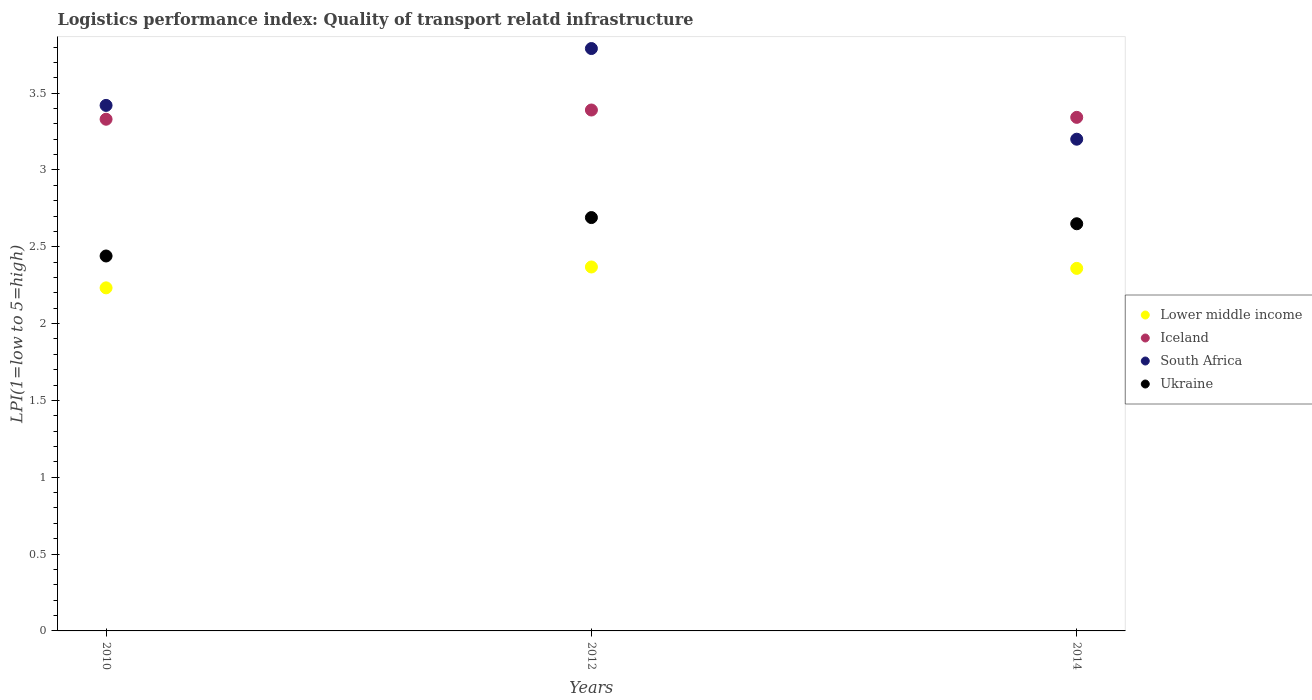What is the logistics performance index in Ukraine in 2012?
Keep it short and to the point. 2.69. Across all years, what is the maximum logistics performance index in Iceland?
Offer a very short reply. 3.39. Across all years, what is the minimum logistics performance index in Iceland?
Ensure brevity in your answer.  3.33. In which year was the logistics performance index in Lower middle income minimum?
Provide a succinct answer. 2010. What is the total logistics performance index in Iceland in the graph?
Offer a terse response. 10.06. What is the difference between the logistics performance index in Ukraine in 2012 and that in 2014?
Give a very brief answer. 0.04. What is the difference between the logistics performance index in South Africa in 2014 and the logistics performance index in Iceland in 2012?
Ensure brevity in your answer.  -0.19. What is the average logistics performance index in Iceland per year?
Offer a terse response. 3.35. In the year 2010, what is the difference between the logistics performance index in South Africa and logistics performance index in Iceland?
Your answer should be very brief. 0.09. What is the ratio of the logistics performance index in Lower middle income in 2010 to that in 2012?
Give a very brief answer. 0.94. Is the logistics performance index in South Africa in 2010 less than that in 2012?
Provide a short and direct response. Yes. Is the difference between the logistics performance index in South Africa in 2010 and 2014 greater than the difference between the logistics performance index in Iceland in 2010 and 2014?
Offer a very short reply. Yes. What is the difference between the highest and the second highest logistics performance index in Ukraine?
Provide a short and direct response. 0.04. What is the difference between the highest and the lowest logistics performance index in Lower middle income?
Your answer should be compact. 0.14. In how many years, is the logistics performance index in Ukraine greater than the average logistics performance index in Ukraine taken over all years?
Your answer should be compact. 2. Does the logistics performance index in Lower middle income monotonically increase over the years?
Provide a short and direct response. No. Is the logistics performance index in Iceland strictly less than the logistics performance index in Lower middle income over the years?
Provide a short and direct response. No. How many years are there in the graph?
Offer a very short reply. 3. Does the graph contain any zero values?
Ensure brevity in your answer.  No. Does the graph contain grids?
Your response must be concise. No. Where does the legend appear in the graph?
Provide a succinct answer. Center right. What is the title of the graph?
Offer a very short reply. Logistics performance index: Quality of transport relatd infrastructure. What is the label or title of the Y-axis?
Ensure brevity in your answer.  LPI(1=low to 5=high). What is the LPI(1=low to 5=high) in Lower middle income in 2010?
Your answer should be compact. 2.23. What is the LPI(1=low to 5=high) in Iceland in 2010?
Give a very brief answer. 3.33. What is the LPI(1=low to 5=high) in South Africa in 2010?
Provide a short and direct response. 3.42. What is the LPI(1=low to 5=high) of Ukraine in 2010?
Provide a short and direct response. 2.44. What is the LPI(1=low to 5=high) in Lower middle income in 2012?
Your answer should be very brief. 2.37. What is the LPI(1=low to 5=high) of Iceland in 2012?
Offer a terse response. 3.39. What is the LPI(1=low to 5=high) of South Africa in 2012?
Your response must be concise. 3.79. What is the LPI(1=low to 5=high) in Ukraine in 2012?
Ensure brevity in your answer.  2.69. What is the LPI(1=low to 5=high) of Lower middle income in 2014?
Make the answer very short. 2.36. What is the LPI(1=low to 5=high) of Iceland in 2014?
Provide a succinct answer. 3.34. What is the LPI(1=low to 5=high) in South Africa in 2014?
Make the answer very short. 3.2. What is the LPI(1=low to 5=high) in Ukraine in 2014?
Make the answer very short. 2.65. Across all years, what is the maximum LPI(1=low to 5=high) of Lower middle income?
Your answer should be compact. 2.37. Across all years, what is the maximum LPI(1=low to 5=high) in Iceland?
Your answer should be compact. 3.39. Across all years, what is the maximum LPI(1=low to 5=high) in South Africa?
Offer a very short reply. 3.79. Across all years, what is the maximum LPI(1=low to 5=high) in Ukraine?
Your answer should be very brief. 2.69. Across all years, what is the minimum LPI(1=low to 5=high) in Lower middle income?
Make the answer very short. 2.23. Across all years, what is the minimum LPI(1=low to 5=high) of Iceland?
Keep it short and to the point. 3.33. Across all years, what is the minimum LPI(1=low to 5=high) in South Africa?
Make the answer very short. 3.2. Across all years, what is the minimum LPI(1=low to 5=high) of Ukraine?
Give a very brief answer. 2.44. What is the total LPI(1=low to 5=high) of Lower middle income in the graph?
Your answer should be very brief. 6.96. What is the total LPI(1=low to 5=high) of Iceland in the graph?
Provide a succinct answer. 10.06. What is the total LPI(1=low to 5=high) in South Africa in the graph?
Provide a short and direct response. 10.41. What is the total LPI(1=low to 5=high) of Ukraine in the graph?
Provide a succinct answer. 7.78. What is the difference between the LPI(1=low to 5=high) in Lower middle income in 2010 and that in 2012?
Ensure brevity in your answer.  -0.14. What is the difference between the LPI(1=low to 5=high) of Iceland in 2010 and that in 2012?
Keep it short and to the point. -0.06. What is the difference between the LPI(1=low to 5=high) in South Africa in 2010 and that in 2012?
Your answer should be very brief. -0.37. What is the difference between the LPI(1=low to 5=high) of Lower middle income in 2010 and that in 2014?
Your answer should be very brief. -0.13. What is the difference between the LPI(1=low to 5=high) in Iceland in 2010 and that in 2014?
Give a very brief answer. -0.01. What is the difference between the LPI(1=low to 5=high) of South Africa in 2010 and that in 2014?
Give a very brief answer. 0.22. What is the difference between the LPI(1=low to 5=high) in Ukraine in 2010 and that in 2014?
Make the answer very short. -0.21. What is the difference between the LPI(1=low to 5=high) of Lower middle income in 2012 and that in 2014?
Your answer should be very brief. 0.01. What is the difference between the LPI(1=low to 5=high) in Iceland in 2012 and that in 2014?
Your response must be concise. 0.05. What is the difference between the LPI(1=low to 5=high) of South Africa in 2012 and that in 2014?
Make the answer very short. 0.59. What is the difference between the LPI(1=low to 5=high) of Ukraine in 2012 and that in 2014?
Provide a short and direct response. 0.04. What is the difference between the LPI(1=low to 5=high) of Lower middle income in 2010 and the LPI(1=low to 5=high) of Iceland in 2012?
Keep it short and to the point. -1.16. What is the difference between the LPI(1=low to 5=high) in Lower middle income in 2010 and the LPI(1=low to 5=high) in South Africa in 2012?
Ensure brevity in your answer.  -1.56. What is the difference between the LPI(1=low to 5=high) in Lower middle income in 2010 and the LPI(1=low to 5=high) in Ukraine in 2012?
Keep it short and to the point. -0.46. What is the difference between the LPI(1=low to 5=high) in Iceland in 2010 and the LPI(1=low to 5=high) in South Africa in 2012?
Offer a terse response. -0.46. What is the difference between the LPI(1=low to 5=high) of Iceland in 2010 and the LPI(1=low to 5=high) of Ukraine in 2012?
Ensure brevity in your answer.  0.64. What is the difference between the LPI(1=low to 5=high) in South Africa in 2010 and the LPI(1=low to 5=high) in Ukraine in 2012?
Keep it short and to the point. 0.73. What is the difference between the LPI(1=low to 5=high) in Lower middle income in 2010 and the LPI(1=low to 5=high) in Iceland in 2014?
Make the answer very short. -1.11. What is the difference between the LPI(1=low to 5=high) in Lower middle income in 2010 and the LPI(1=low to 5=high) in South Africa in 2014?
Your answer should be very brief. -0.97. What is the difference between the LPI(1=low to 5=high) in Lower middle income in 2010 and the LPI(1=low to 5=high) in Ukraine in 2014?
Your answer should be compact. -0.42. What is the difference between the LPI(1=low to 5=high) of Iceland in 2010 and the LPI(1=low to 5=high) of South Africa in 2014?
Your answer should be very brief. 0.13. What is the difference between the LPI(1=low to 5=high) in Iceland in 2010 and the LPI(1=low to 5=high) in Ukraine in 2014?
Your answer should be compact. 0.68. What is the difference between the LPI(1=low to 5=high) of South Africa in 2010 and the LPI(1=low to 5=high) of Ukraine in 2014?
Make the answer very short. 0.77. What is the difference between the LPI(1=low to 5=high) of Lower middle income in 2012 and the LPI(1=low to 5=high) of Iceland in 2014?
Provide a short and direct response. -0.97. What is the difference between the LPI(1=low to 5=high) in Lower middle income in 2012 and the LPI(1=low to 5=high) in South Africa in 2014?
Make the answer very short. -0.83. What is the difference between the LPI(1=low to 5=high) of Lower middle income in 2012 and the LPI(1=low to 5=high) of Ukraine in 2014?
Offer a terse response. -0.28. What is the difference between the LPI(1=low to 5=high) in Iceland in 2012 and the LPI(1=low to 5=high) in South Africa in 2014?
Keep it short and to the point. 0.19. What is the difference between the LPI(1=low to 5=high) in Iceland in 2012 and the LPI(1=low to 5=high) in Ukraine in 2014?
Keep it short and to the point. 0.74. What is the difference between the LPI(1=low to 5=high) in South Africa in 2012 and the LPI(1=low to 5=high) in Ukraine in 2014?
Your response must be concise. 1.14. What is the average LPI(1=low to 5=high) of Lower middle income per year?
Provide a short and direct response. 2.32. What is the average LPI(1=low to 5=high) in Iceland per year?
Keep it short and to the point. 3.35. What is the average LPI(1=low to 5=high) of South Africa per year?
Provide a short and direct response. 3.47. What is the average LPI(1=low to 5=high) in Ukraine per year?
Your answer should be compact. 2.59. In the year 2010, what is the difference between the LPI(1=low to 5=high) of Lower middle income and LPI(1=low to 5=high) of Iceland?
Give a very brief answer. -1.1. In the year 2010, what is the difference between the LPI(1=low to 5=high) of Lower middle income and LPI(1=low to 5=high) of South Africa?
Your answer should be very brief. -1.19. In the year 2010, what is the difference between the LPI(1=low to 5=high) of Lower middle income and LPI(1=low to 5=high) of Ukraine?
Offer a terse response. -0.21. In the year 2010, what is the difference between the LPI(1=low to 5=high) of Iceland and LPI(1=low to 5=high) of South Africa?
Your answer should be very brief. -0.09. In the year 2010, what is the difference between the LPI(1=low to 5=high) of Iceland and LPI(1=low to 5=high) of Ukraine?
Keep it short and to the point. 0.89. In the year 2012, what is the difference between the LPI(1=low to 5=high) in Lower middle income and LPI(1=low to 5=high) in Iceland?
Provide a short and direct response. -1.02. In the year 2012, what is the difference between the LPI(1=low to 5=high) in Lower middle income and LPI(1=low to 5=high) in South Africa?
Offer a terse response. -1.42. In the year 2012, what is the difference between the LPI(1=low to 5=high) in Lower middle income and LPI(1=low to 5=high) in Ukraine?
Make the answer very short. -0.32. In the year 2012, what is the difference between the LPI(1=low to 5=high) in Iceland and LPI(1=low to 5=high) in South Africa?
Your answer should be very brief. -0.4. In the year 2014, what is the difference between the LPI(1=low to 5=high) of Lower middle income and LPI(1=low to 5=high) of Iceland?
Keep it short and to the point. -0.98. In the year 2014, what is the difference between the LPI(1=low to 5=high) in Lower middle income and LPI(1=low to 5=high) in South Africa?
Provide a succinct answer. -0.84. In the year 2014, what is the difference between the LPI(1=low to 5=high) of Lower middle income and LPI(1=low to 5=high) of Ukraine?
Your answer should be compact. -0.29. In the year 2014, what is the difference between the LPI(1=low to 5=high) of Iceland and LPI(1=low to 5=high) of South Africa?
Your response must be concise. 0.14. In the year 2014, what is the difference between the LPI(1=low to 5=high) of Iceland and LPI(1=low to 5=high) of Ukraine?
Your answer should be compact. 0.69. In the year 2014, what is the difference between the LPI(1=low to 5=high) of South Africa and LPI(1=low to 5=high) of Ukraine?
Offer a very short reply. 0.55. What is the ratio of the LPI(1=low to 5=high) of Lower middle income in 2010 to that in 2012?
Your response must be concise. 0.94. What is the ratio of the LPI(1=low to 5=high) of Iceland in 2010 to that in 2012?
Give a very brief answer. 0.98. What is the ratio of the LPI(1=low to 5=high) of South Africa in 2010 to that in 2012?
Ensure brevity in your answer.  0.9. What is the ratio of the LPI(1=low to 5=high) of Ukraine in 2010 to that in 2012?
Your answer should be compact. 0.91. What is the ratio of the LPI(1=low to 5=high) of Lower middle income in 2010 to that in 2014?
Offer a very short reply. 0.95. What is the ratio of the LPI(1=low to 5=high) of Iceland in 2010 to that in 2014?
Ensure brevity in your answer.  1. What is the ratio of the LPI(1=low to 5=high) of South Africa in 2010 to that in 2014?
Your answer should be very brief. 1.07. What is the ratio of the LPI(1=low to 5=high) in Ukraine in 2010 to that in 2014?
Keep it short and to the point. 0.92. What is the ratio of the LPI(1=low to 5=high) in Lower middle income in 2012 to that in 2014?
Make the answer very short. 1. What is the ratio of the LPI(1=low to 5=high) in Iceland in 2012 to that in 2014?
Your response must be concise. 1.01. What is the ratio of the LPI(1=low to 5=high) of South Africa in 2012 to that in 2014?
Make the answer very short. 1.18. What is the ratio of the LPI(1=low to 5=high) in Ukraine in 2012 to that in 2014?
Ensure brevity in your answer.  1.02. What is the difference between the highest and the second highest LPI(1=low to 5=high) of Lower middle income?
Make the answer very short. 0.01. What is the difference between the highest and the second highest LPI(1=low to 5=high) of Iceland?
Provide a short and direct response. 0.05. What is the difference between the highest and the second highest LPI(1=low to 5=high) of South Africa?
Your answer should be very brief. 0.37. What is the difference between the highest and the second highest LPI(1=low to 5=high) of Ukraine?
Make the answer very short. 0.04. What is the difference between the highest and the lowest LPI(1=low to 5=high) of Lower middle income?
Your answer should be compact. 0.14. What is the difference between the highest and the lowest LPI(1=low to 5=high) of Iceland?
Offer a terse response. 0.06. What is the difference between the highest and the lowest LPI(1=low to 5=high) in South Africa?
Make the answer very short. 0.59. What is the difference between the highest and the lowest LPI(1=low to 5=high) of Ukraine?
Give a very brief answer. 0.25. 